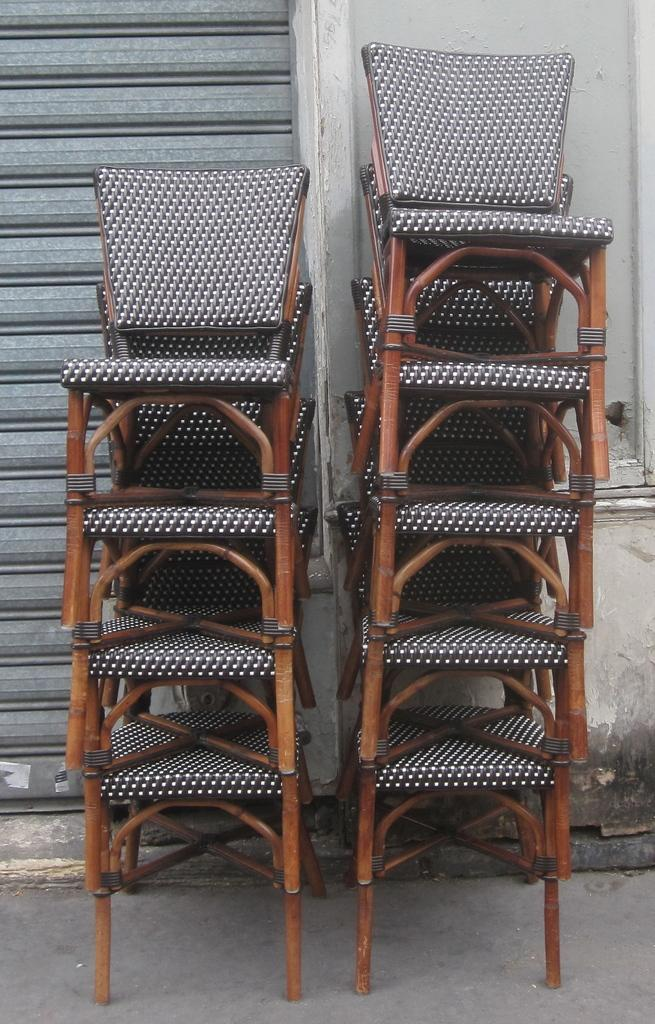What objects are present in the image that are meant for sitting? There are empty chairs in the image. How are the chairs arranged in the image? The chairs are stacked one upon another. What is located behind the chairs in the image? There is a wall behind the chairs. What is the condition of the shutter in the image? There is a closed shutter in the image. What type of cake is being served in the image? There is no cake present in the image; it features empty chairs stacked one upon another with a wall and a closed shutter in the background. How many cattle can be seen grazing in the image? There are no cattle present in the image. 